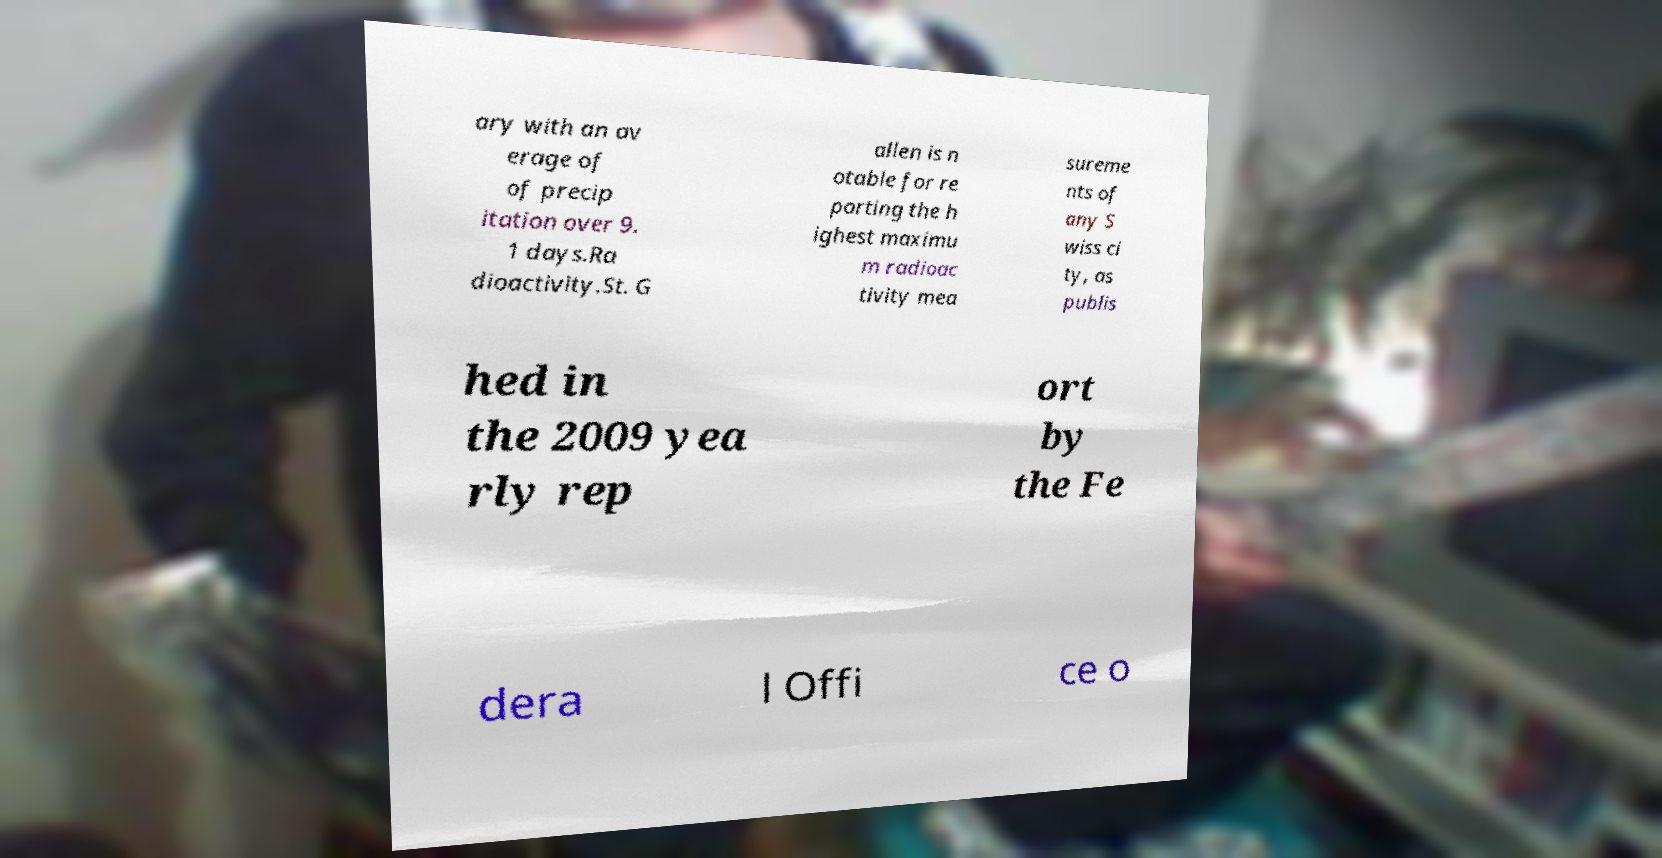What messages or text are displayed in this image? I need them in a readable, typed format. ary with an av erage of of precip itation over 9. 1 days.Ra dioactivity.St. G allen is n otable for re porting the h ighest maximu m radioac tivity mea sureme nts of any S wiss ci ty, as publis hed in the 2009 yea rly rep ort by the Fe dera l Offi ce o 